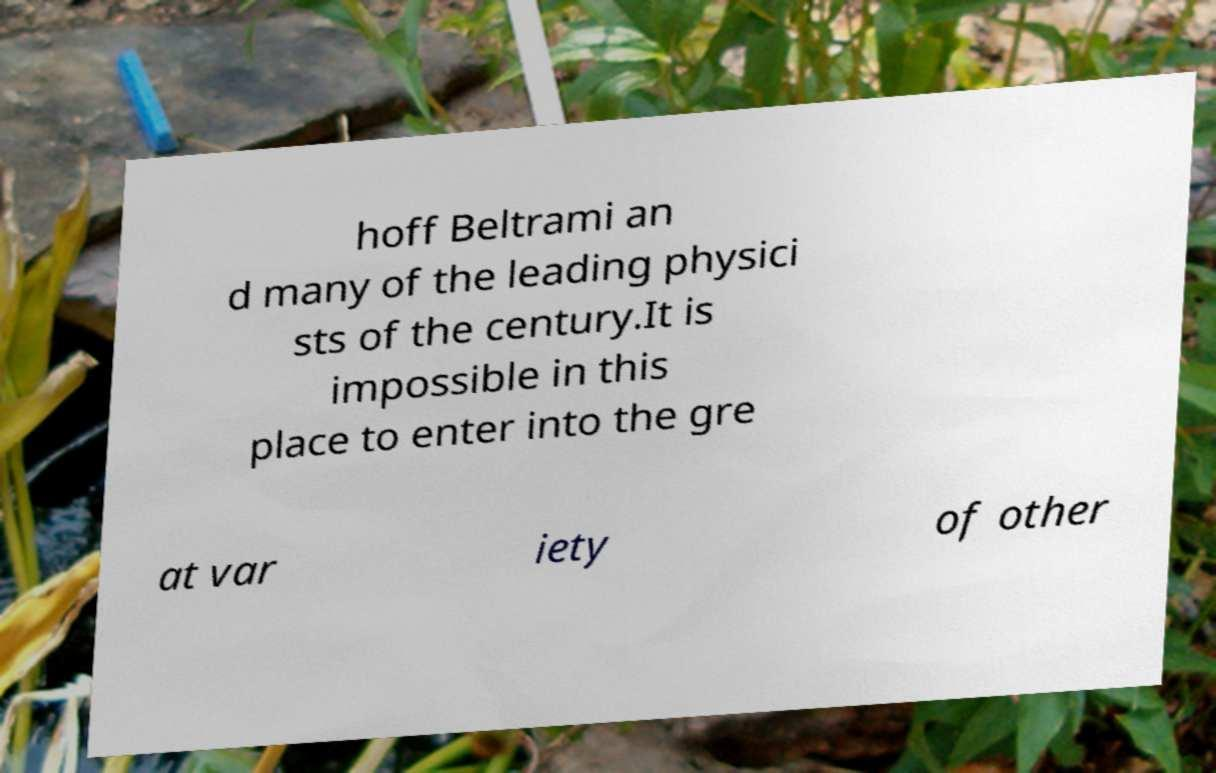What messages or text are displayed in this image? I need them in a readable, typed format. hoff Beltrami an d many of the leading physici sts of the century.It is impossible in this place to enter into the gre at var iety of other 